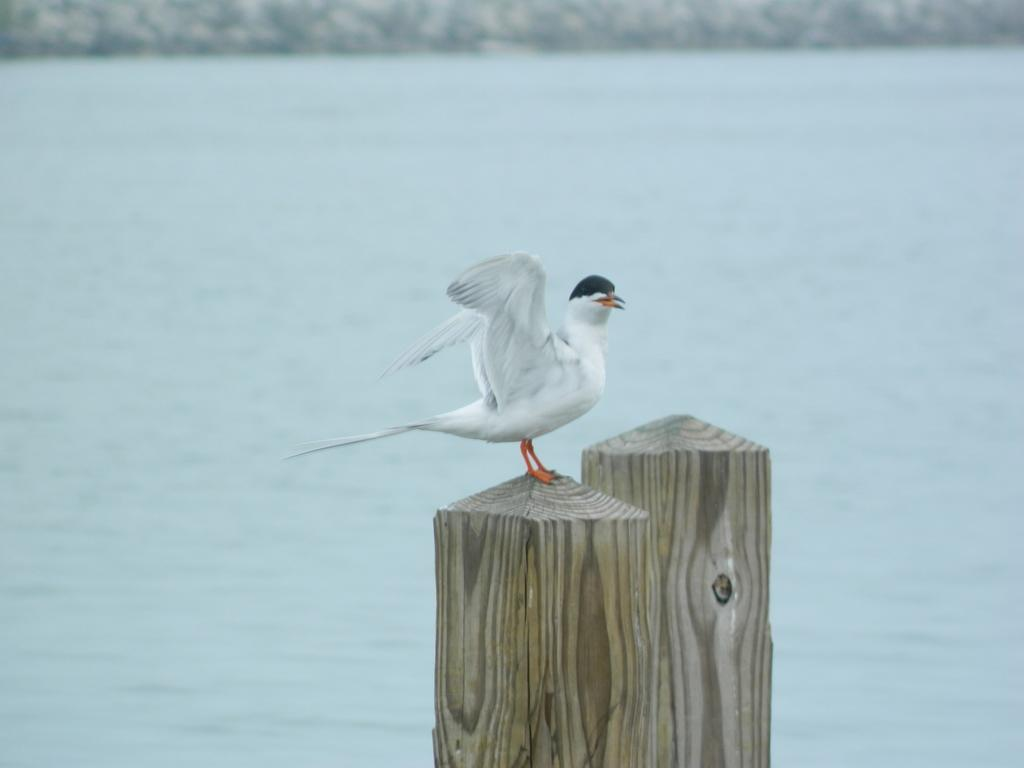What type of animal can be seen in the image? There is a bird in the image. Where is the bird located? The bird is on a wooden pole. What can be seen in the background of the image? There is water visible in the background of the image. What type of pain is the bird experiencing in the image? There is no indication in the image that the bird is experiencing any pain. 